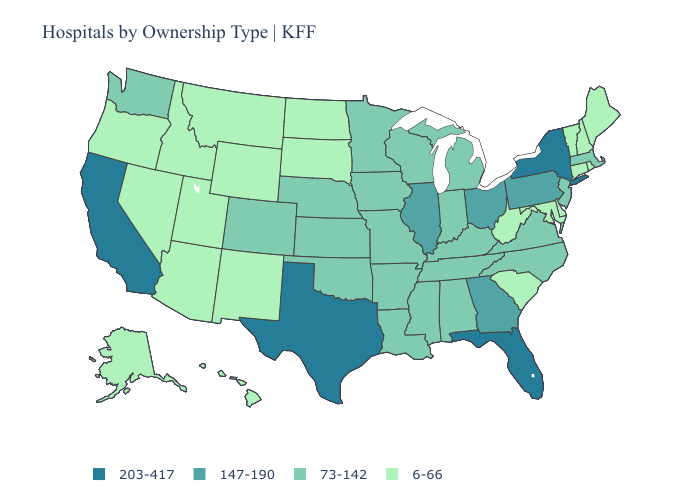Does the first symbol in the legend represent the smallest category?
Be succinct. No. What is the value of Arizona?
Answer briefly. 6-66. What is the lowest value in the South?
Give a very brief answer. 6-66. Does the map have missing data?
Write a very short answer. No. Name the states that have a value in the range 203-417?
Concise answer only. California, Florida, New York, Texas. What is the value of North Carolina?
Keep it brief. 73-142. Does Ohio have the highest value in the MidWest?
Give a very brief answer. Yes. Which states have the highest value in the USA?
Be succinct. California, Florida, New York, Texas. Does Alabama have the lowest value in the South?
Give a very brief answer. No. What is the highest value in the MidWest ?
Short answer required. 147-190. How many symbols are there in the legend?
Give a very brief answer. 4. What is the lowest value in the MidWest?
Concise answer only. 6-66. What is the value of North Dakota?
Concise answer only. 6-66. Name the states that have a value in the range 147-190?
Answer briefly. Georgia, Illinois, Ohio, Pennsylvania. Which states have the lowest value in the West?
Short answer required. Alaska, Arizona, Hawaii, Idaho, Montana, Nevada, New Mexico, Oregon, Utah, Wyoming. 